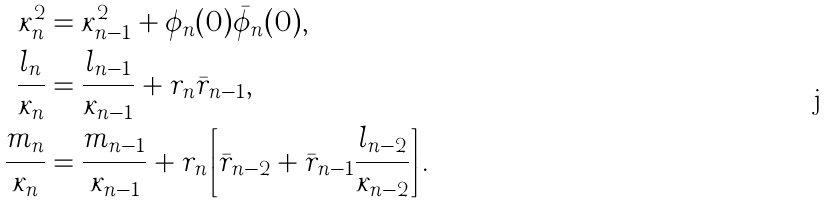Convert formula to latex. <formula><loc_0><loc_0><loc_500><loc_500>\kappa _ { n } ^ { 2 } & = \kappa _ { n - 1 } ^ { 2 } + \phi _ { n } ( 0 ) \bar { \phi } _ { n } ( 0 ) , \\ \frac { l _ { n } } { \kappa _ { n } } & = \frac { l _ { n - 1 } } { \kappa _ { n - 1 } } + r _ { n } \bar { r } _ { n - 1 } , \\ \frac { m _ { n } } { \kappa _ { n } } & = \frac { m _ { n - 1 } } { \kappa _ { n - 1 } } + r _ { n } \left [ \bar { r } _ { n - 2 } + \bar { r } _ { n - 1 } \frac { l _ { n - 2 } } { \kappa _ { n - 2 } } \right ] .</formula> 